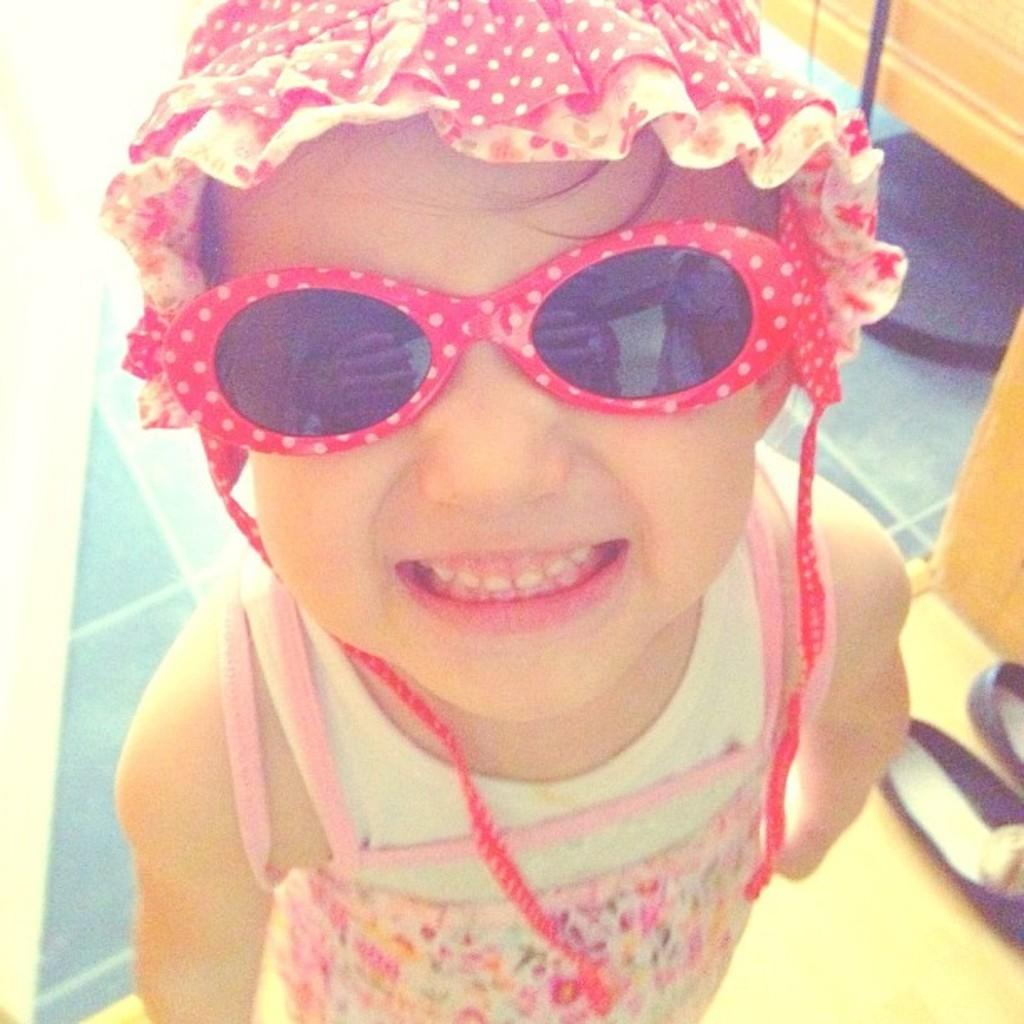What is the main subject of the image? There is a child in the image. What is the child wearing on their head? The child is wearing a cap. What is the child wearing to protect their eyes? The child is wearing goggles. What type of footwear is visible beside the child? There are sandals beside the child. What can be seen in the background of the image? There is a floor visible in the background of the image, and there are objects present as well. What type of knowledge is the child acquiring while wearing the goggles in the image? There is no indication in the image that the child is acquiring any specific knowledge while wearing the goggles. Is the child walking on a trail in the image? There is no trail visible in the image; it only shows a child wearing a cap, goggles, and sandals, with objects in the background. 